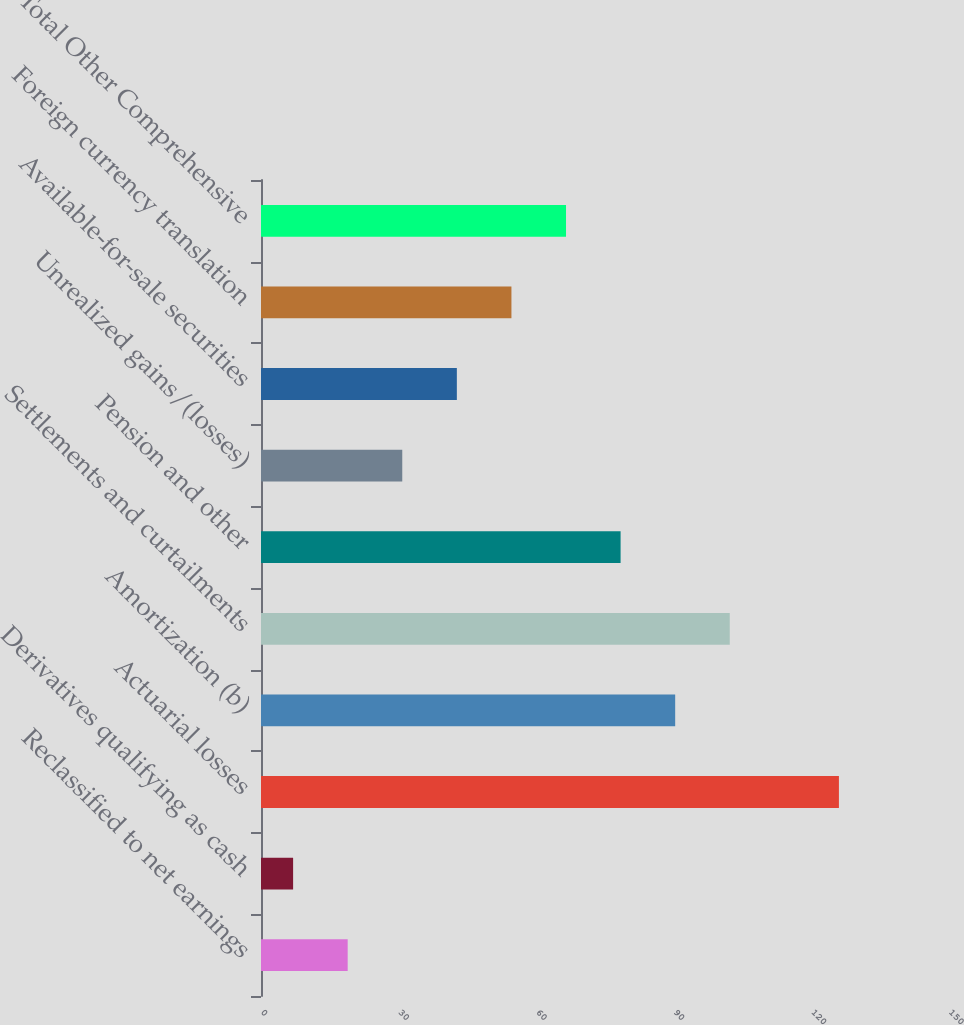Convert chart. <chart><loc_0><loc_0><loc_500><loc_500><bar_chart><fcel>Reclassified to net earnings<fcel>Derivatives qualifying as cash<fcel>Actuarial losses<fcel>Amortization (b)<fcel>Settlements and curtailments<fcel>Pension and other<fcel>Unrealized gains/(losses)<fcel>Available-for-sale securities<fcel>Foreign currency translation<fcel>Total Other Comprehensive<nl><fcel>18.9<fcel>7<fcel>126<fcel>90.3<fcel>102.2<fcel>78.4<fcel>30.8<fcel>42.7<fcel>54.6<fcel>66.5<nl></chart> 